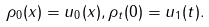<formula> <loc_0><loc_0><loc_500><loc_500>\rho _ { 0 } ( x ) = u _ { 0 } ( x ) , \rho _ { t } ( 0 ) = u _ { 1 } ( t ) .</formula> 